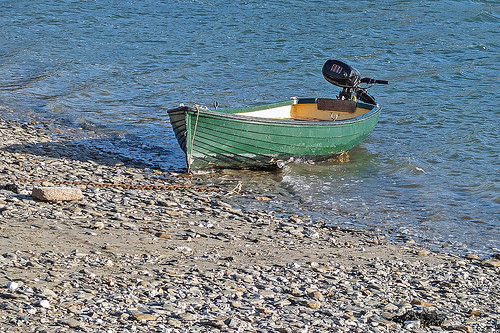<image>
Is the motor on the boat? Yes. Looking at the image, I can see the motor is positioned on top of the boat, with the boat providing support. 